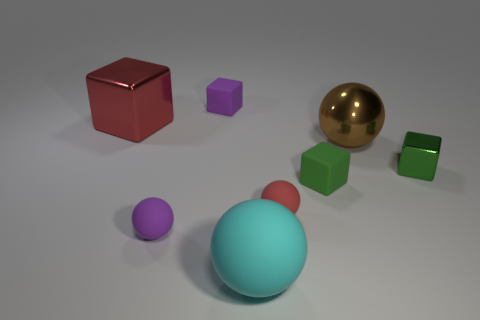Are there any big yellow cylinders made of the same material as the large red cube?
Your answer should be very brief. No. The small purple thing that is behind the metallic block left of the small matte object right of the small red object is what shape?
Keep it short and to the point. Cube. Is the size of the brown thing the same as the purple ball to the right of the big red metal cube?
Keep it short and to the point. No. The tiny thing that is both behind the green rubber block and in front of the big red object has what shape?
Provide a short and direct response. Cube. What number of tiny objects are purple balls or red blocks?
Make the answer very short. 1. Is the number of brown spheres that are in front of the small green rubber thing the same as the number of small rubber cubes to the left of the tiny red matte sphere?
Offer a terse response. No. What number of other things are the same color as the big rubber thing?
Offer a very short reply. 0. Is the number of rubber cubes that are right of the large cyan ball the same as the number of small red spheres?
Offer a terse response. Yes. Do the brown metal sphere and the purple block have the same size?
Ensure brevity in your answer.  No. The cube that is to the left of the metallic ball and in front of the large red metal cube is made of what material?
Provide a succinct answer. Rubber. 